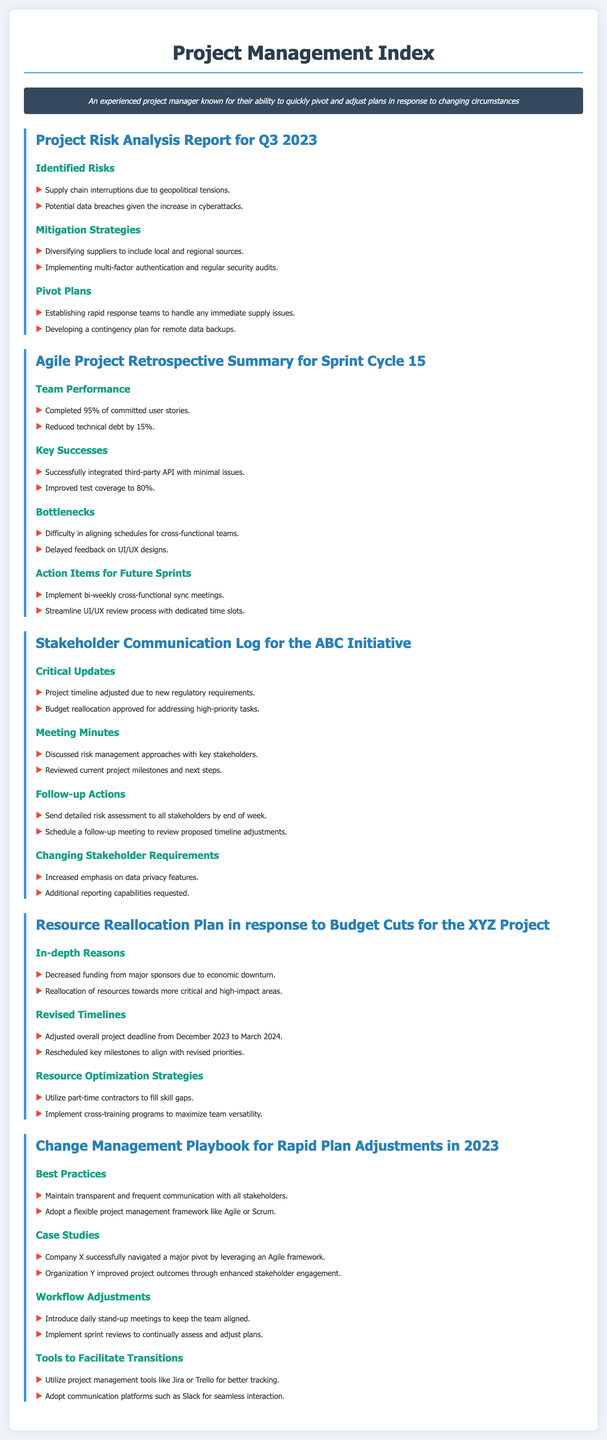what is the date range of the Project Risk Analysis Report? The document mentions the report is for Q3 2023, which typically includes July, August, and September.
Answer: Q3 2023 how many user stories were completed in Sprint Cycle 15? It states that 95% of committed user stories were completed during this Sprint Cycle.
Answer: 95% what was a key success in the Agile Project Retrospective? The section highlights that a successful integration of a third-party API occurred.
Answer: Successfully integrated third-party API what is the adjusted overall project deadline for the XYZ Project? It indicates that the project deadline was adjusted from December 2023 to March 2024.
Answer: March 2024 which project management tools are suggested for better tracking? The document mentions utilizing tools like Jira or Trello for project management.
Answer: Jira or Trello what change in stakeholder requirements is mentioned in the document? It notes an increased emphasis on data privacy features as one of the changing requirements.
Answer: Data privacy features how did the organization improve project outcomes according to the case studies? The case studies indicate that enhanced stakeholder engagement improved project outcomes.
Answer: Enhanced stakeholder engagement what is one of the mitigation strategies mentioned for identified risks? The document indicates diversifying suppliers as one of the mitigation strategies.
Answer: Diversifying suppliers what was one of the follow-up actions from the Stakeholder Communication Log? It mentions sending a detailed risk assessment to all stakeholders as a follow-up action.
Answer: Send detailed risk assessment 